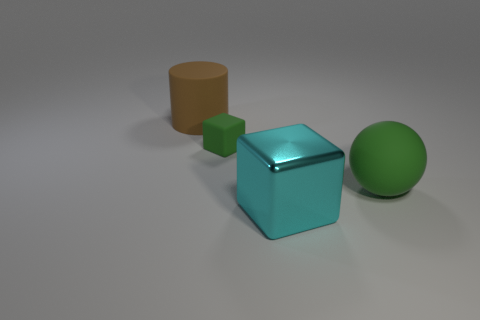Add 2 brown rubber objects. How many objects exist? 6 Subtract all spheres. How many objects are left? 3 Add 1 tiny matte things. How many tiny matte things are left? 2 Add 4 tiny yellow metal balls. How many tiny yellow metal balls exist? 4 Subtract 0 red spheres. How many objects are left? 4 Subtract all big purple metallic blocks. Subtract all big cyan objects. How many objects are left? 3 